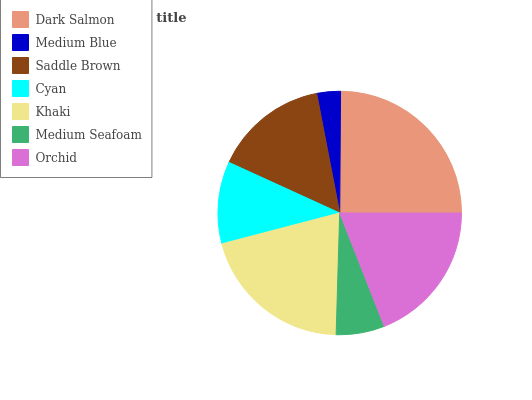Is Medium Blue the minimum?
Answer yes or no. Yes. Is Dark Salmon the maximum?
Answer yes or no. Yes. Is Saddle Brown the minimum?
Answer yes or no. No. Is Saddle Brown the maximum?
Answer yes or no. No. Is Saddle Brown greater than Medium Blue?
Answer yes or no. Yes. Is Medium Blue less than Saddle Brown?
Answer yes or no. Yes. Is Medium Blue greater than Saddle Brown?
Answer yes or no. No. Is Saddle Brown less than Medium Blue?
Answer yes or no. No. Is Saddle Brown the high median?
Answer yes or no. Yes. Is Saddle Brown the low median?
Answer yes or no. Yes. Is Khaki the high median?
Answer yes or no. No. Is Khaki the low median?
Answer yes or no. No. 